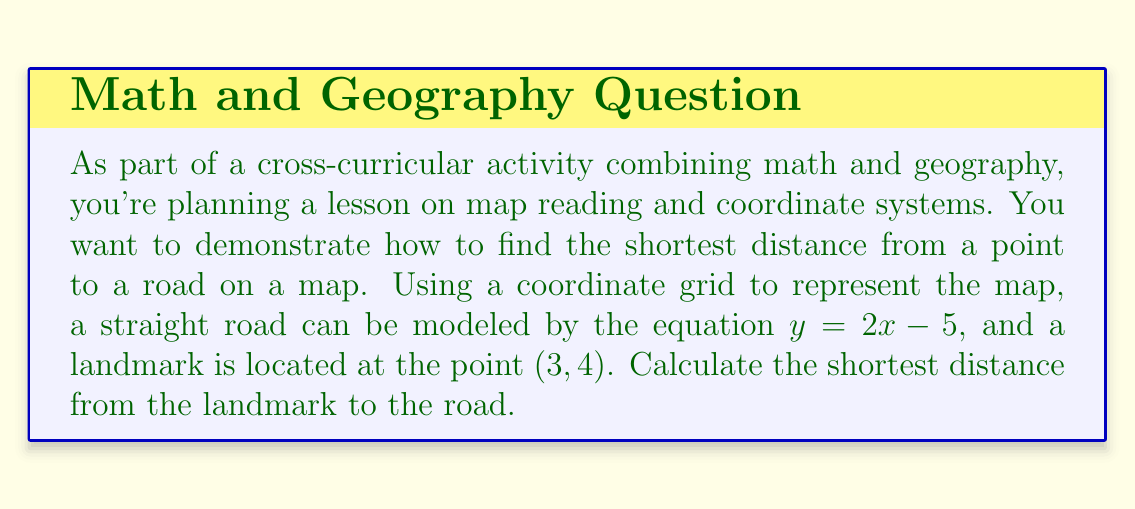What is the answer to this math problem? Let's approach this step-by-step:

1) The general formula for the distance $d$ from a point $(x_0, y_0)$ to a line $ax + by + c = 0$ is:

   $$d = \frac{|ax_0 + by_0 + c|}{\sqrt{a^2 + b^2}}$$

2) Our line is $y = 2x - 5$, which we need to rewrite in the form $ax + by + c = 0$:
   
   $y = 2x - 5$
   $y - 2x + 5 = 0$

   So, $a = -2$, $b = 1$, and $c = 5$

3) Our point $(x_0, y_0)$ is $(3, 4)$

4) Now let's substitute these values into our distance formula:

   $$d = \frac{|-2(3) + 1(4) + 5|}{\sqrt{(-2)^2 + 1^2}}$$

5) Simplify the numerator:
   
   $$d = \frac{|-6 + 4 + 5|}{\sqrt{4 + 1}} = \frac{|3|}{\sqrt{5}}$$

6) Simplify:

   $$d = \frac{3}{\sqrt{5}}$$

7) If we want to express this as a decimal, we can calculate:

   $$d \approx 1.34$$

Thus, the shortest distance from the point to the line is $\frac{3}{\sqrt{5}}$ units, or approximately 1.34 units.

[asy]
import geometry;

size(200);
real xmin=-1, xmax=5, ymin=-1, ymax=7;
real xscale=40, yscale=40;

draw((xmin,0)--(xmax,0),Arrow);
draw((0,ymin)--(0,ymax),Arrow);

for(int i=xmin; i<=xmax; ++i)
  draw((i,ymin/50)--(i,ymax/50));
for(int i=ymin; i<=ymax; ++i)
  draw((xmin/50,i)--(xmax/50,i));

Label lx=Label("$x$",position=EndPoint);
Label ly=Label("$y$",position=EndPoint);

draw((xmin,2*xmin-5)--(xmax,2*xmax-5),blue);
dot((3,4),red);

draw((3,4)--(3,-1),dashed);
draw((3,-1)--(1.5,-1),dashed);
draw((3,4)--(1.5,-1),red);

label("$(3,4)$",(3,4),NE);
label("$y=2x-5$",(4,3),SE);

[/asy]
Answer: $\frac{3}{\sqrt{5}}$ units (or approximately 1.34 units) 